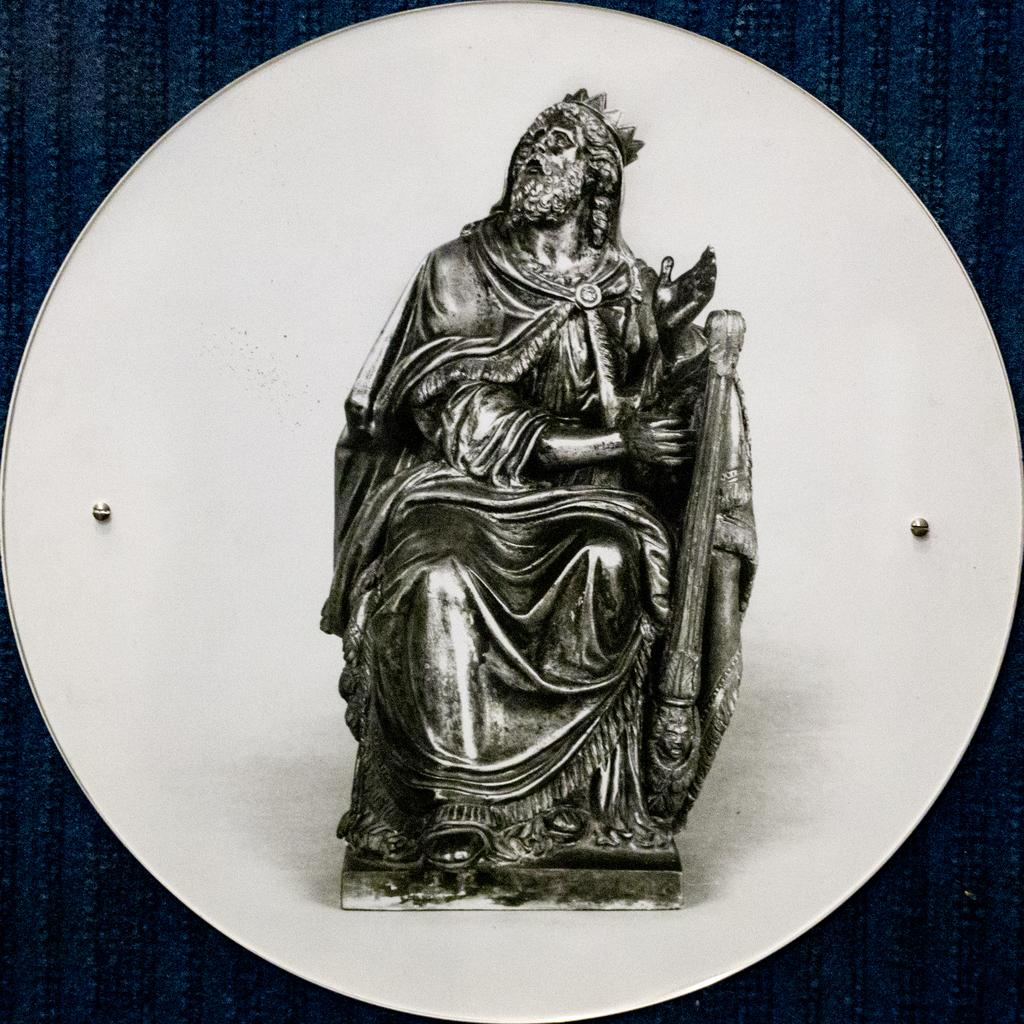What is the main subject of the image? There is a sculpture in the image. Can you describe any other objects or features in the image? There are two nails in the image. What type of can is depicted in the image? There is no can present in the image; it only features a sculpture and two nails. How many fingers can be seen touching the sculpture in the image? There are no fingers visible in the image. 